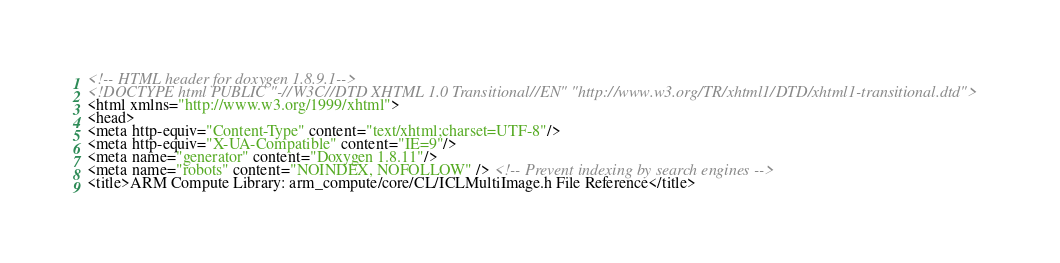Convert code to text. <code><loc_0><loc_0><loc_500><loc_500><_HTML_><!-- HTML header for doxygen 1.8.9.1-->
<!DOCTYPE html PUBLIC "-//W3C//DTD XHTML 1.0 Transitional//EN" "http://www.w3.org/TR/xhtml1/DTD/xhtml1-transitional.dtd">
<html xmlns="http://www.w3.org/1999/xhtml">
<head>
<meta http-equiv="Content-Type" content="text/xhtml;charset=UTF-8"/>
<meta http-equiv="X-UA-Compatible" content="IE=9"/>
<meta name="generator" content="Doxygen 1.8.11"/>
<meta name="robots" content="NOINDEX, NOFOLLOW" /> <!-- Prevent indexing by search engines -->
<title>ARM Compute Library: arm_compute/core/CL/ICLMultiImage.h File Reference</title></code> 